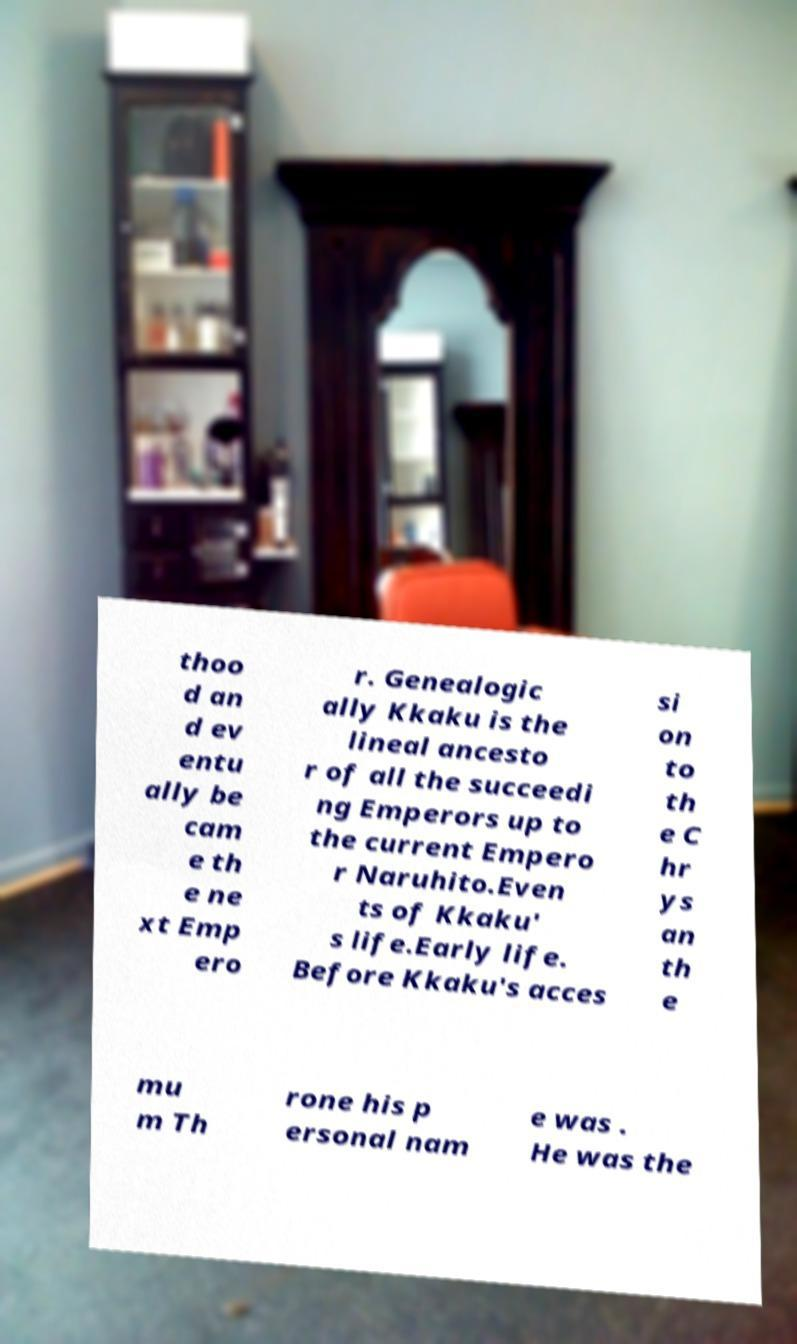Please read and relay the text visible in this image. What does it say? thoo d an d ev entu ally be cam e th e ne xt Emp ero r. Genealogic ally Kkaku is the lineal ancesto r of all the succeedi ng Emperors up to the current Empero r Naruhito.Even ts of Kkaku' s life.Early life. Before Kkaku's acces si on to th e C hr ys an th e mu m Th rone his p ersonal nam e was . He was the 